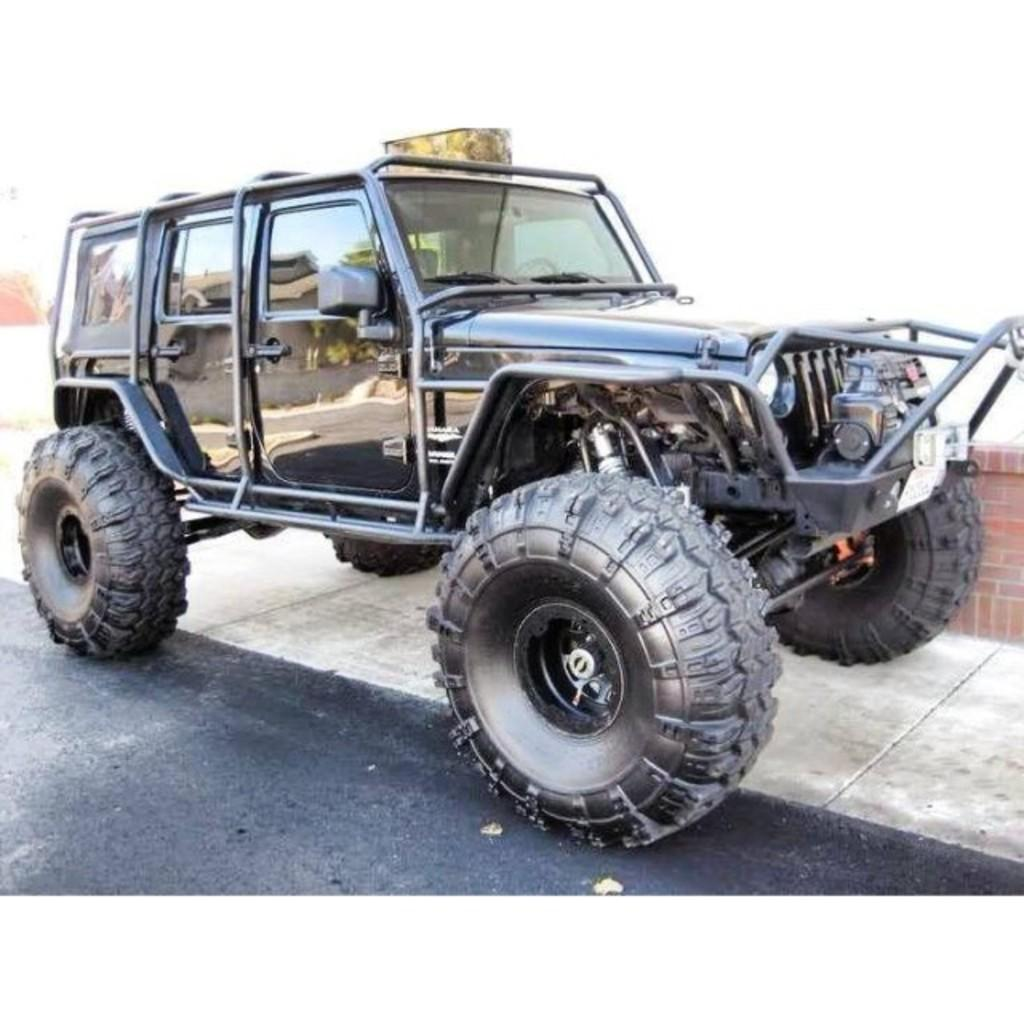What type of vehicle is in the image? There is a jeep in the image. What color is the jeep? The jeep is black in color. What can be seen at the bottom of the image? There is a road visible at the bottom of the image. Can you see any quicksand near the jeep in the image? No, there is no quicksand present in the image. How many toads are sitting on the jeep in the image? There are no toads present in the image. 